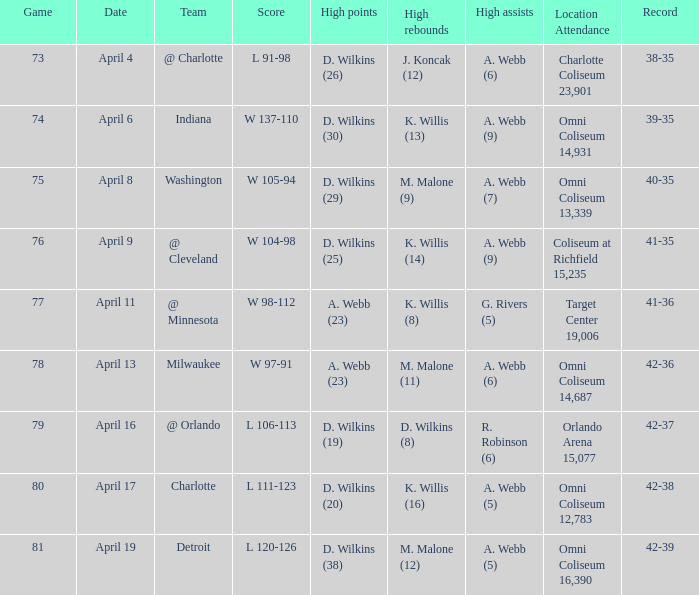How many individuals had the peak scores when a. webb (7) had the top assists? 1.0. 